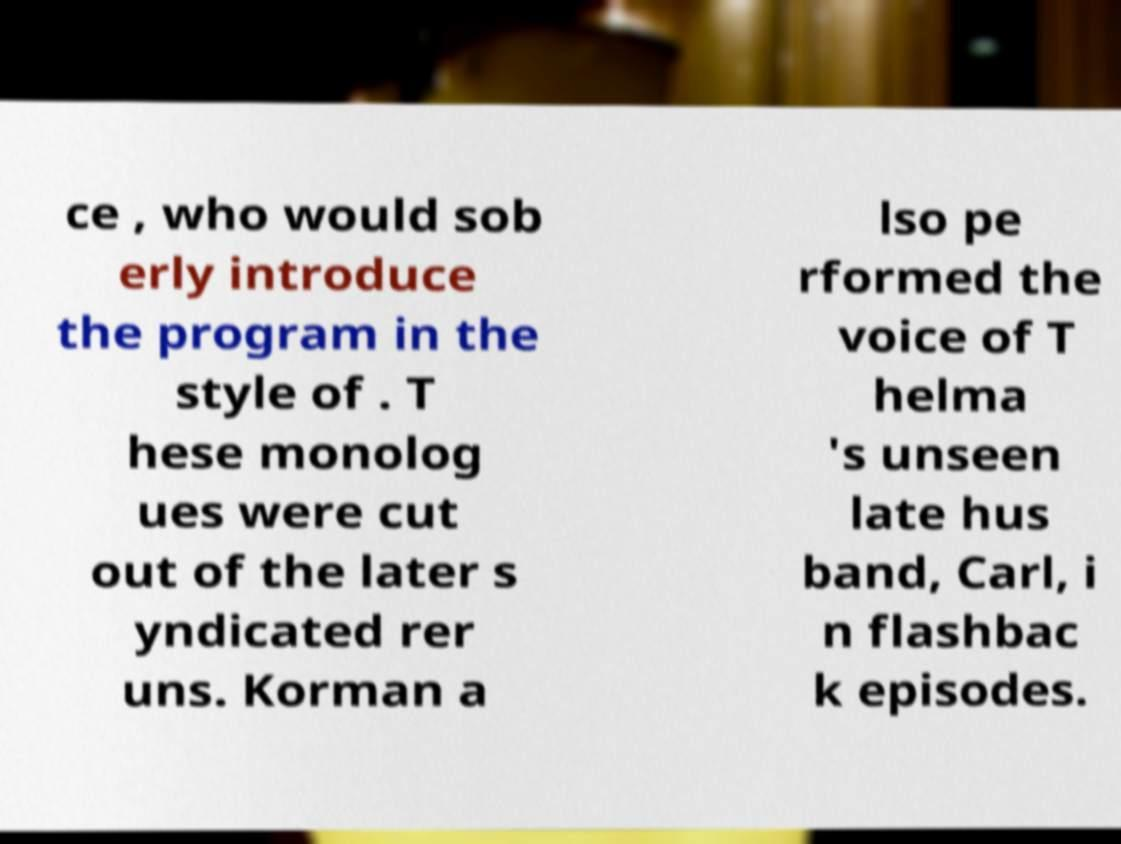Could you extract and type out the text from this image? ce , who would sob erly introduce the program in the style of . T hese monolog ues were cut out of the later s yndicated rer uns. Korman a lso pe rformed the voice of T helma 's unseen late hus band, Carl, i n flashbac k episodes. 